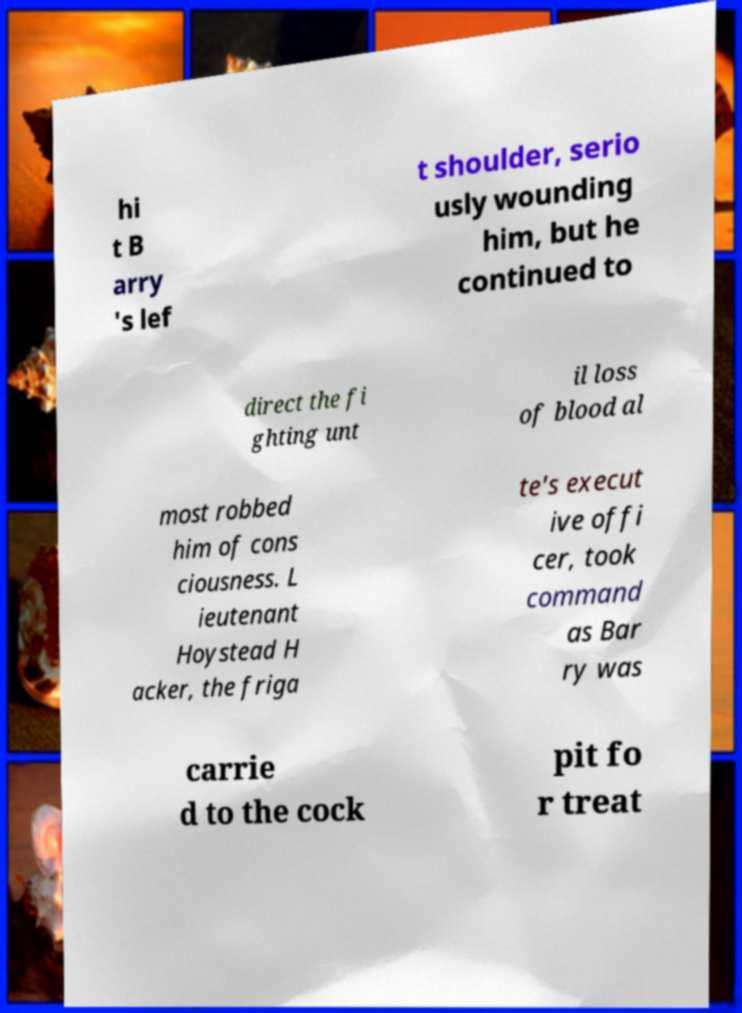Please identify and transcribe the text found in this image. hi t B arry 's lef t shoulder, serio usly wounding him, but he continued to direct the fi ghting unt il loss of blood al most robbed him of cons ciousness. L ieutenant Hoystead H acker, the friga te's execut ive offi cer, took command as Bar ry was carrie d to the cock pit fo r treat 